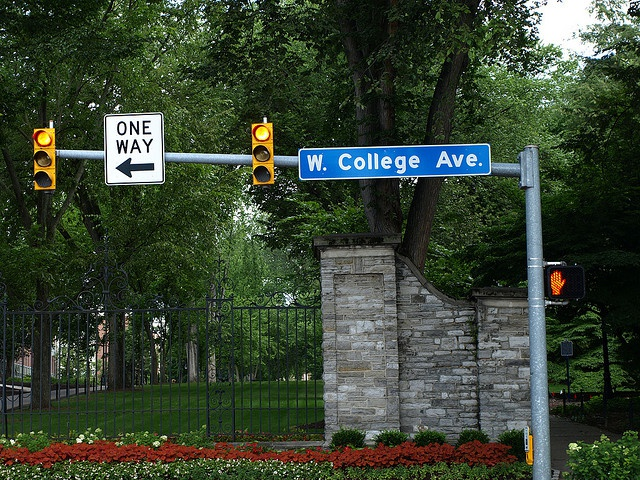Describe the objects in this image and their specific colors. I can see traffic light in darkgreen, black, orange, gold, and maroon tones, traffic light in black, orange, gold, and olive tones, and traffic light in darkgreen, black, red, and orange tones in this image. 